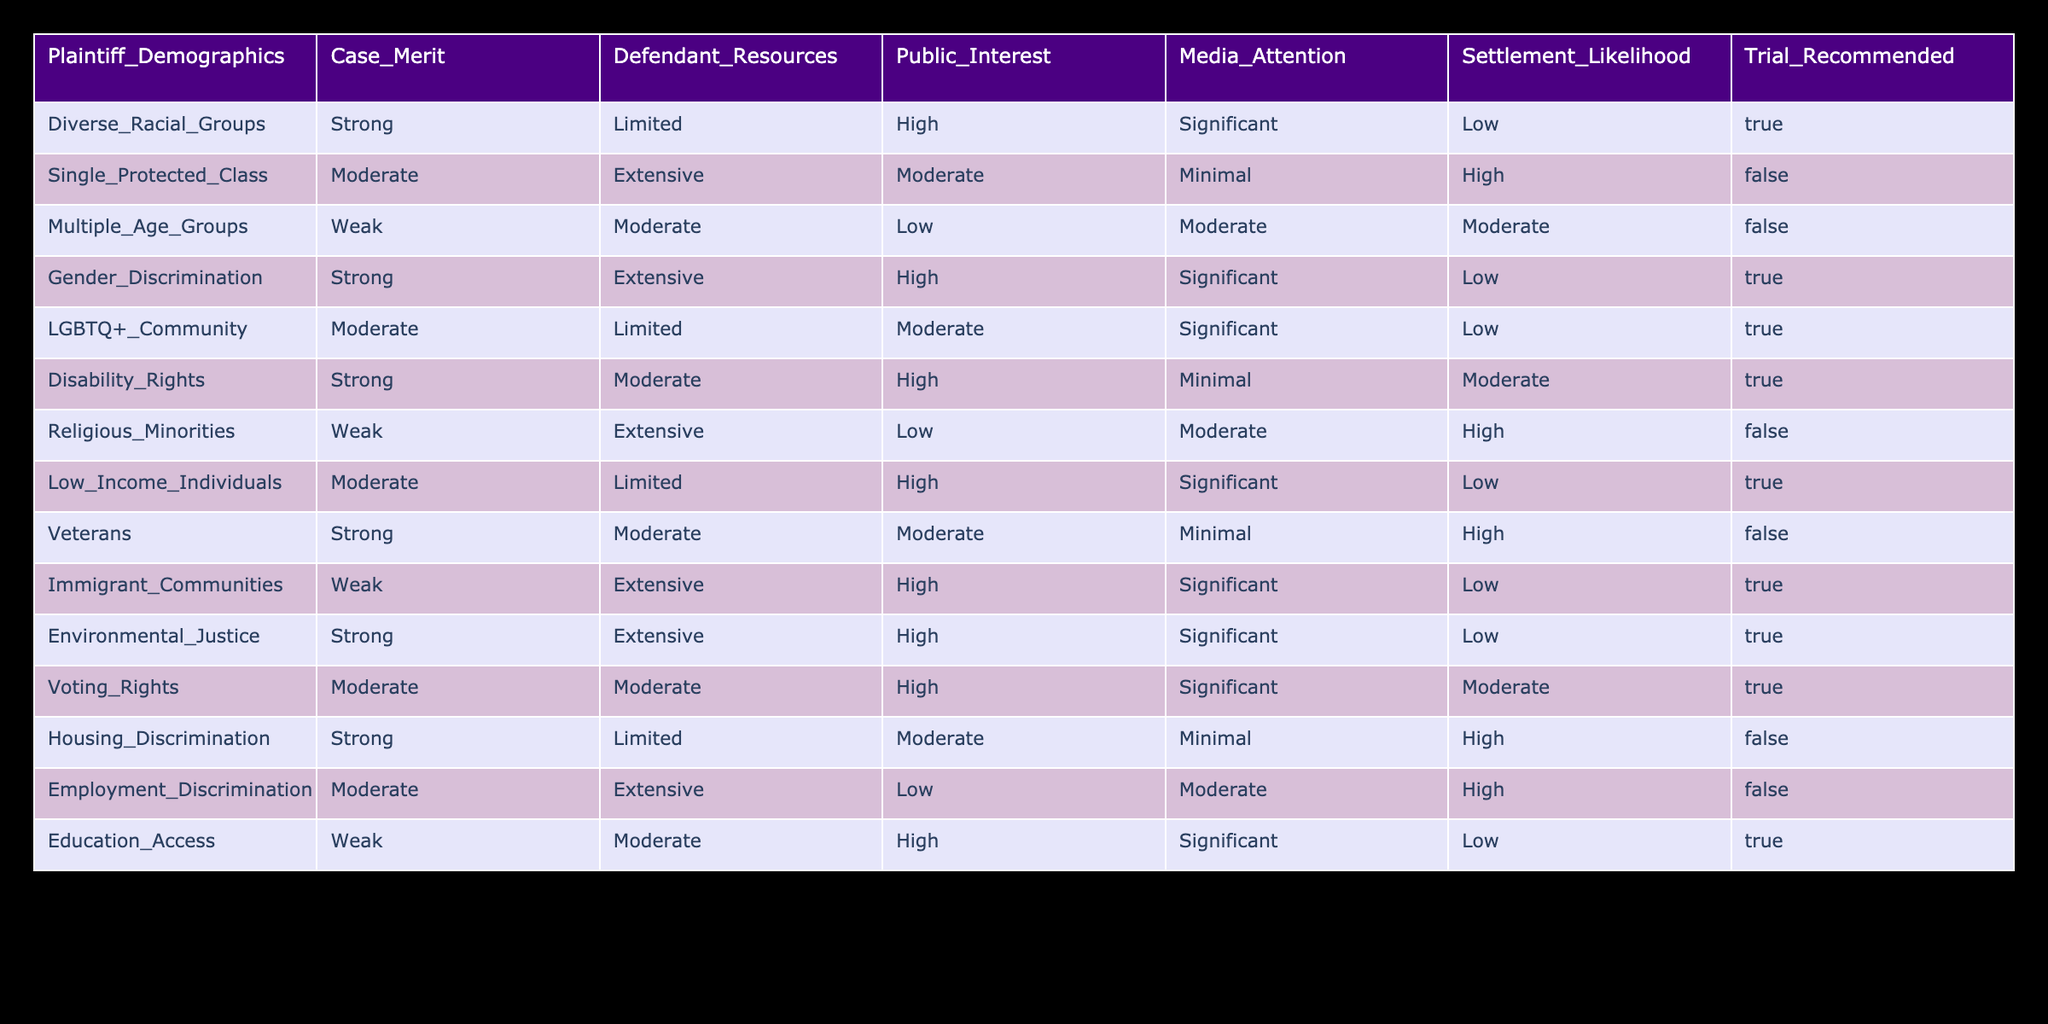What demographic group has the highest likelihood of settlement? By reviewing the "Settlement Likelihood" column, we can see that the "Single Protected Class" has a high likelihood of settlement as indicated by its value of "High." This makes it the group with the highest settlement likelihood.
Answer: High How many class action lawsuits have a "True" recommendation for trial? We can count the entries in the "Trial Recommended" column where the value is "True." Upon checking, there are six such entries: Diverse Racial Groups, Gender Discrimination, LGBTQ+ Community, Disability Rights, Low Income Individuals, and Education Access.
Answer: 6 Is there a relationship between "Public Interest" and "Trial Recommended"? We check the "Public Interest" and "Trial Recommended" columns. "High" public interest generally correlates with "True" trial recommendations in several cases (Diverse Racial Groups, Gender Discrimination, etc.), but not consistently. This indicates that while there is some relationship, it is not definitive.
Answer: No What is the total number of cases with "Weak" case merit? Looking at the "Case Merit" column, there are three cases with "Weak" merit: Multiple Age Groups, Religious Minorities, and Immigrant Communities, giving us a total of three cases.
Answer: 3 Which demographic group is linked to "Limited" defendant resources and has a "True" trial recommendation? From the "Defendant Resources" and "Trial Recommended" columns, we find that "Diverse Racial Groups" and "Low Income Individuals" are the only groups that meet these criteria. Both have "Limited" resources, and both have a "True" recommendation for trial.
Answer: Diverse Racial Groups, Low Income Individuals What percentage of the cases with "High" media attention also have "High" public interest? We identify the cases that have both "High" media attention and "High" public interest. In the table, only the "Diverse Racial Groups," "Gender Discrimination," "Immigrant Communities," "Environmental Justice," and "Voting Rights" meet these criteria. There are 5 of 14 cases, giving us about 36%.
Answer: 36% Are there any class action lawsuits that have "Strong" case merit but a "False" recommendation for trial? By examining the rows, we can see that "Housing Discrimination" with "Strong" case merit indeed has a "False" recommendation for trial. This confirms that it is possible to have strong case merit yet not recommend trial.
Answer: Yes How many total cases recommend a trial, and what proportion of these cases have "Limited" defendant resources? We start by counting all cases that recommend trial, which are six. Next, we find those with "Limited" defendant resources, which are "Diverse Racial Groups" and "Low Income Individuals," giving us two cases. Therefore, the proportion is 2 out of 6, or about 33%.
Answer: 33% 